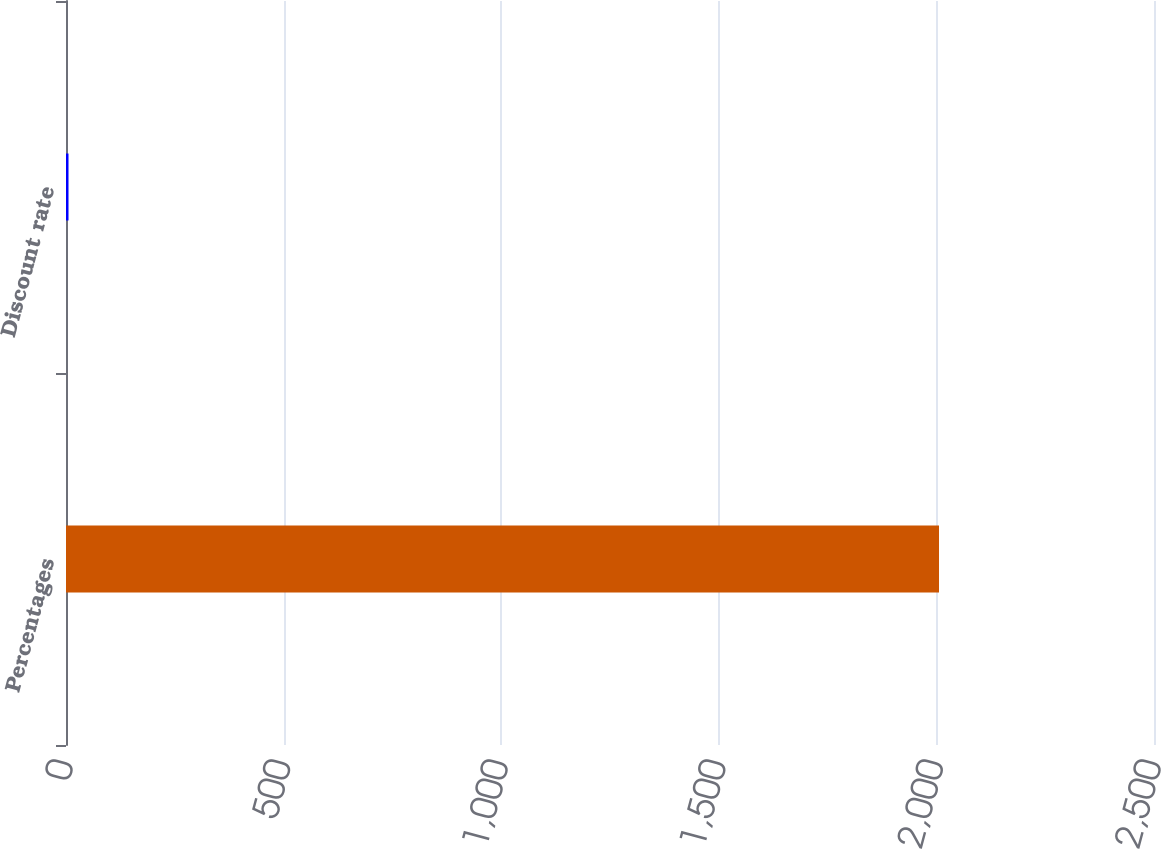Convert chart to OTSL. <chart><loc_0><loc_0><loc_500><loc_500><bar_chart><fcel>Percentages<fcel>Discount rate<nl><fcel>2006<fcel>5.75<nl></chart> 